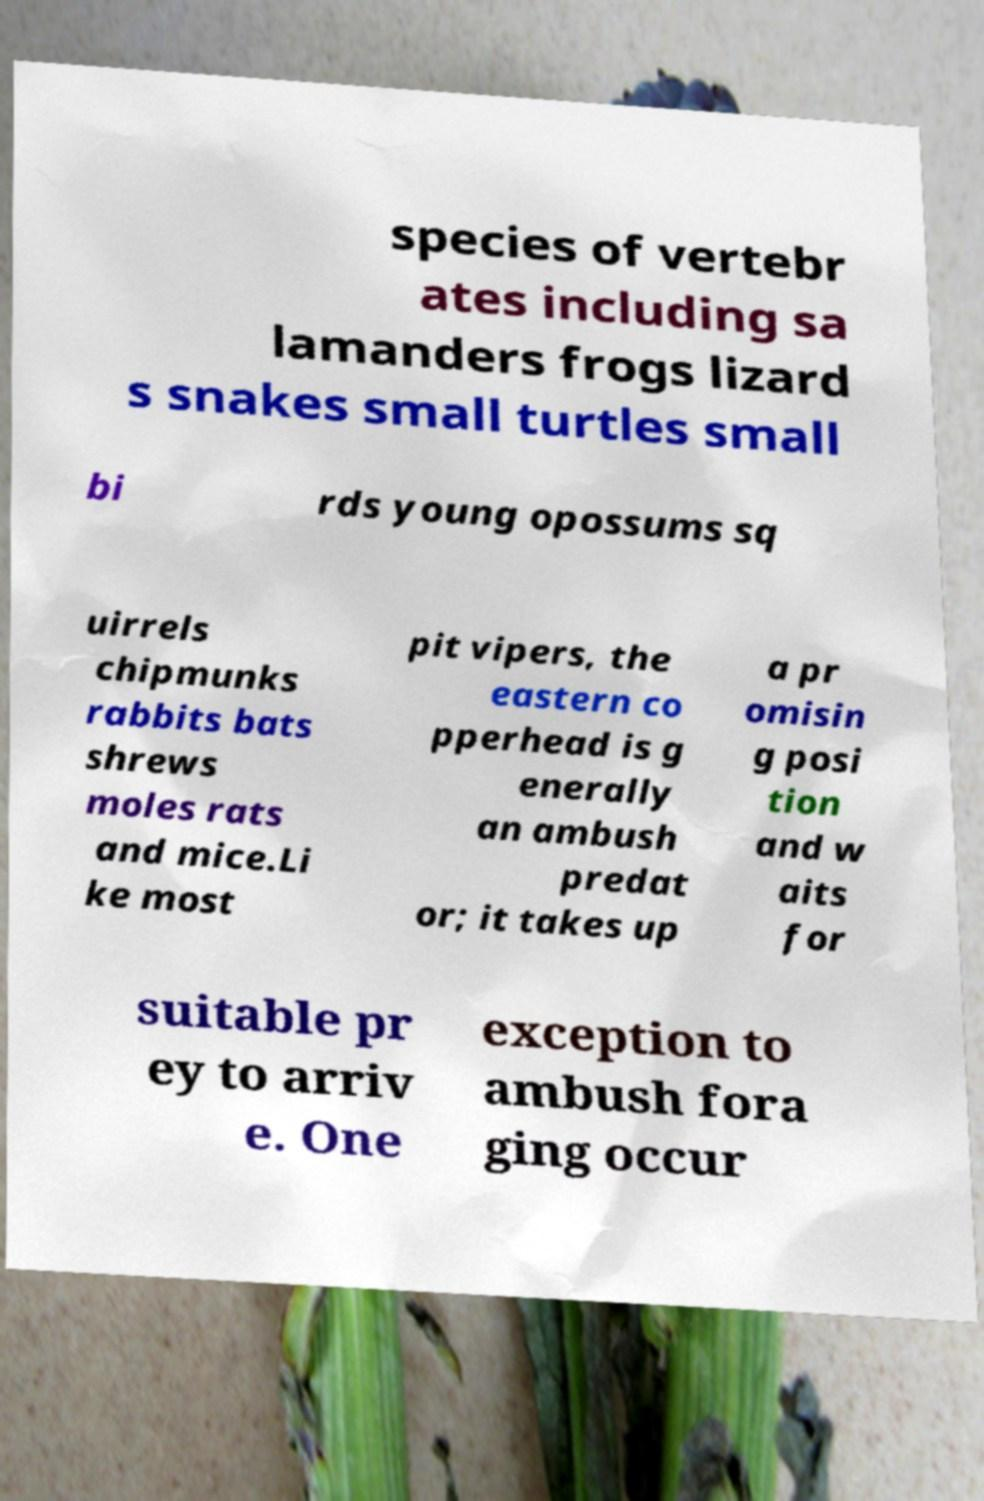I need the written content from this picture converted into text. Can you do that? species of vertebr ates including sa lamanders frogs lizard s snakes small turtles small bi rds young opossums sq uirrels chipmunks rabbits bats shrews moles rats and mice.Li ke most pit vipers, the eastern co pperhead is g enerally an ambush predat or; it takes up a pr omisin g posi tion and w aits for suitable pr ey to arriv e. One exception to ambush fora ging occur 